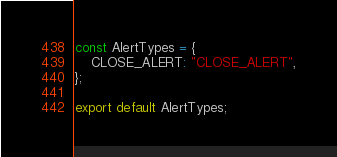<code> <loc_0><loc_0><loc_500><loc_500><_JavaScript_>const AlertTypes = {
	CLOSE_ALERT: "CLOSE_ALERT",
};

export default AlertTypes;
</code> 